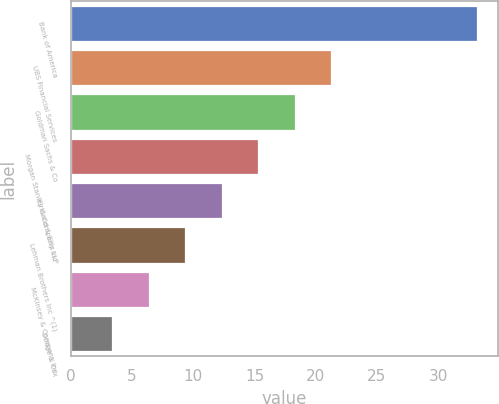<chart> <loc_0><loc_0><loc_500><loc_500><bar_chart><fcel>Bank of America<fcel>UBS Financial Services<fcel>Goldman Sachs & Co<fcel>Morgan Stanley & Company Inc<fcel>Kirkland & Ellis LLP<fcel>Lehman Brothers Inc ^(1)<fcel>McKinsey & Company Inc<fcel>Dodge & Cox<nl><fcel>33.2<fcel>21.28<fcel>18.3<fcel>15.32<fcel>12.34<fcel>9.36<fcel>6.38<fcel>3.4<nl></chart> 